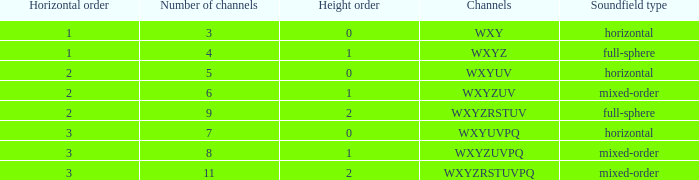If the channels is wxyzuv, what is the number of channels? 6.0. 